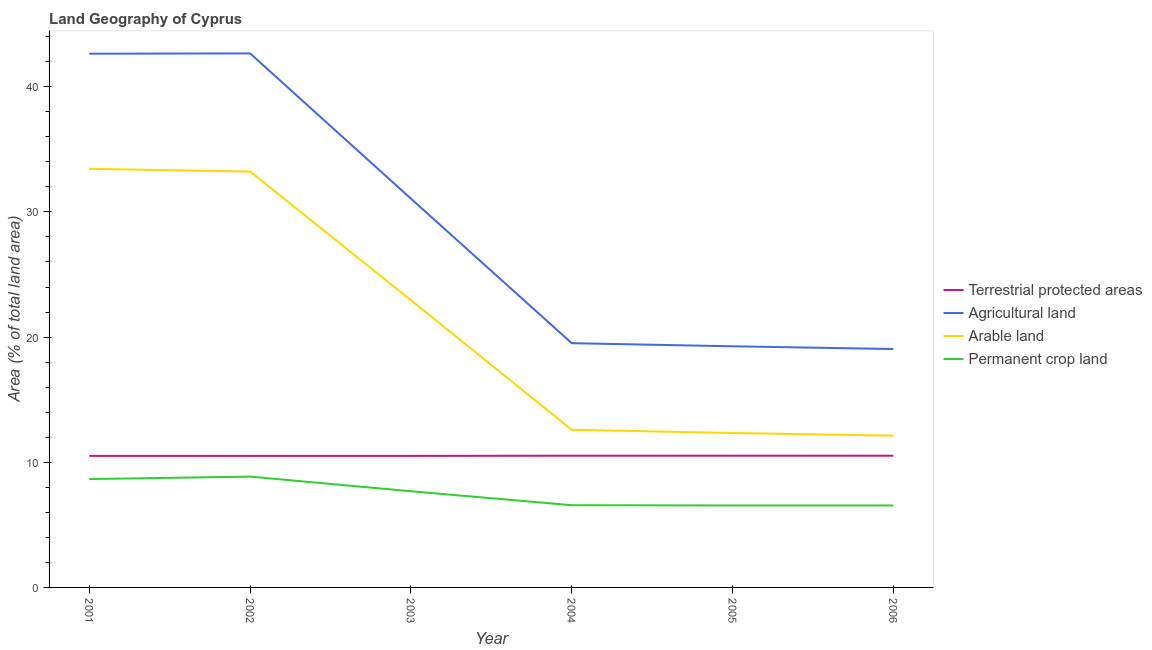How many different coloured lines are there?
Your answer should be compact. 4. What is the percentage of land under terrestrial protection in 2006?
Give a very brief answer. 10.52. Across all years, what is the maximum percentage of area under permanent crop land?
Your answer should be very brief. 8.85. Across all years, what is the minimum percentage of area under agricultural land?
Keep it short and to the point. 19.05. In which year was the percentage of land under terrestrial protection minimum?
Offer a terse response. 2001. What is the total percentage of area under agricultural land in the graph?
Your response must be concise. 174.19. What is the difference between the percentage of land under terrestrial protection in 2001 and that in 2005?
Provide a succinct answer. -0.02. What is the difference between the percentage of area under arable land in 2004 and the percentage of area under permanent crop land in 2006?
Make the answer very short. 6.05. What is the average percentage of area under agricultural land per year?
Offer a very short reply. 29.03. In the year 2001, what is the difference between the percentage of area under agricultural land and percentage of area under arable land?
Ensure brevity in your answer.  9.2. What is the ratio of the percentage of area under permanent crop land in 2003 to that in 2005?
Offer a terse response. 1.17. Is the percentage of land under terrestrial protection in 2002 less than that in 2004?
Make the answer very short. Yes. What is the difference between the highest and the second highest percentage of area under permanent crop land?
Provide a succinct answer. 0.19. What is the difference between the highest and the lowest percentage of area under agricultural land?
Your answer should be compact. 23.61. Is it the case that in every year, the sum of the percentage of area under agricultural land and percentage of area under arable land is greater than the sum of percentage of land under terrestrial protection and percentage of area under permanent crop land?
Make the answer very short. Yes. Is it the case that in every year, the sum of the percentage of land under terrestrial protection and percentage of area under agricultural land is greater than the percentage of area under arable land?
Give a very brief answer. Yes. Is the percentage of area under permanent crop land strictly less than the percentage of area under arable land over the years?
Give a very brief answer. Yes. How many years are there in the graph?
Keep it short and to the point. 6. Are the values on the major ticks of Y-axis written in scientific E-notation?
Offer a very short reply. No. Does the graph contain any zero values?
Keep it short and to the point. No. Does the graph contain grids?
Provide a succinct answer. No. How many legend labels are there?
Keep it short and to the point. 4. How are the legend labels stacked?
Keep it short and to the point. Vertical. What is the title of the graph?
Your response must be concise. Land Geography of Cyprus. Does "Public sector management" appear as one of the legend labels in the graph?
Provide a succinct answer. No. What is the label or title of the Y-axis?
Keep it short and to the point. Area (% of total land area). What is the Area (% of total land area) in Terrestrial protected areas in 2001?
Offer a very short reply. 10.51. What is the Area (% of total land area) in Agricultural land in 2001?
Offer a terse response. 42.64. What is the Area (% of total land area) of Arable land in 2001?
Provide a short and direct response. 33.44. What is the Area (% of total land area) of Permanent crop land in 2001?
Provide a short and direct response. 8.66. What is the Area (% of total land area) of Terrestrial protected areas in 2002?
Offer a very short reply. 10.51. What is the Area (% of total land area) of Agricultural land in 2002?
Ensure brevity in your answer.  42.66. What is the Area (% of total land area) in Arable land in 2002?
Offer a very short reply. 33.23. What is the Area (% of total land area) in Permanent crop land in 2002?
Give a very brief answer. 8.85. What is the Area (% of total land area) in Terrestrial protected areas in 2003?
Your response must be concise. 10.51. What is the Area (% of total land area) of Agricultural land in 2003?
Provide a short and direct response. 31.06. What is the Area (% of total land area) of Arable land in 2003?
Your response must be concise. 22.94. What is the Area (% of total land area) in Permanent crop land in 2003?
Keep it short and to the point. 7.68. What is the Area (% of total land area) of Terrestrial protected areas in 2004?
Your answer should be compact. 10.52. What is the Area (% of total land area) of Agricultural land in 2004?
Ensure brevity in your answer.  19.51. What is the Area (% of total land area) in Arable land in 2004?
Your answer should be very brief. 12.6. What is the Area (% of total land area) in Permanent crop land in 2004?
Ensure brevity in your answer.  6.57. What is the Area (% of total land area) of Terrestrial protected areas in 2005?
Provide a short and direct response. 10.52. What is the Area (% of total land area) in Agricultural land in 2005?
Offer a very short reply. 19.26. What is the Area (% of total land area) of Arable land in 2005?
Provide a succinct answer. 12.34. What is the Area (% of total land area) in Permanent crop land in 2005?
Your response must be concise. 6.55. What is the Area (% of total land area) in Terrestrial protected areas in 2006?
Keep it short and to the point. 10.52. What is the Area (% of total land area) in Agricultural land in 2006?
Ensure brevity in your answer.  19.05. What is the Area (% of total land area) of Arable land in 2006?
Make the answer very short. 12.12. What is the Area (% of total land area) of Permanent crop land in 2006?
Give a very brief answer. 6.55. Across all years, what is the maximum Area (% of total land area) of Terrestrial protected areas?
Your response must be concise. 10.52. Across all years, what is the maximum Area (% of total land area) in Agricultural land?
Give a very brief answer. 42.66. Across all years, what is the maximum Area (% of total land area) of Arable land?
Ensure brevity in your answer.  33.44. Across all years, what is the maximum Area (% of total land area) of Permanent crop land?
Your answer should be very brief. 8.85. Across all years, what is the minimum Area (% of total land area) in Terrestrial protected areas?
Offer a very short reply. 10.51. Across all years, what is the minimum Area (% of total land area) in Agricultural land?
Offer a very short reply. 19.05. Across all years, what is the minimum Area (% of total land area) in Arable land?
Make the answer very short. 12.12. Across all years, what is the minimum Area (% of total land area) of Permanent crop land?
Ensure brevity in your answer.  6.55. What is the total Area (% of total land area) in Terrestrial protected areas in the graph?
Your response must be concise. 63.1. What is the total Area (% of total land area) in Agricultural land in the graph?
Make the answer very short. 174.19. What is the total Area (% of total land area) of Arable land in the graph?
Keep it short and to the point. 126.67. What is the total Area (% of total land area) in Permanent crop land in the graph?
Your response must be concise. 44.86. What is the difference between the Area (% of total land area) in Terrestrial protected areas in 2001 and that in 2002?
Your answer should be very brief. 0. What is the difference between the Area (% of total land area) of Agricultural land in 2001 and that in 2002?
Offer a terse response. -0.02. What is the difference between the Area (% of total land area) of Arable land in 2001 and that in 2002?
Provide a short and direct response. 0.22. What is the difference between the Area (% of total land area) in Permanent crop land in 2001 and that in 2002?
Offer a terse response. -0.19. What is the difference between the Area (% of total land area) of Agricultural land in 2001 and that in 2003?
Your answer should be compact. 11.58. What is the difference between the Area (% of total land area) in Arable land in 2001 and that in 2003?
Your answer should be very brief. 10.5. What is the difference between the Area (% of total land area) in Terrestrial protected areas in 2001 and that in 2004?
Ensure brevity in your answer.  -0.02. What is the difference between the Area (% of total land area) in Agricultural land in 2001 and that in 2004?
Offer a terse response. 23.13. What is the difference between the Area (% of total land area) in Arable land in 2001 and that in 2004?
Keep it short and to the point. 20.84. What is the difference between the Area (% of total land area) in Permanent crop land in 2001 and that in 2004?
Make the answer very short. 2.09. What is the difference between the Area (% of total land area) of Terrestrial protected areas in 2001 and that in 2005?
Keep it short and to the point. -0.02. What is the difference between the Area (% of total land area) of Agricultural land in 2001 and that in 2005?
Your response must be concise. 23.38. What is the difference between the Area (% of total land area) of Arable land in 2001 and that in 2005?
Keep it short and to the point. 21.1. What is the difference between the Area (% of total land area) in Permanent crop land in 2001 and that in 2005?
Make the answer very short. 2.11. What is the difference between the Area (% of total land area) in Terrestrial protected areas in 2001 and that in 2006?
Ensure brevity in your answer.  -0.02. What is the difference between the Area (% of total land area) in Agricultural land in 2001 and that in 2006?
Give a very brief answer. 23.59. What is the difference between the Area (% of total land area) in Arable land in 2001 and that in 2006?
Ensure brevity in your answer.  21.32. What is the difference between the Area (% of total land area) of Permanent crop land in 2001 and that in 2006?
Provide a succinct answer. 2.11. What is the difference between the Area (% of total land area) of Terrestrial protected areas in 2002 and that in 2003?
Your answer should be very brief. 0. What is the difference between the Area (% of total land area) in Agricultural land in 2002 and that in 2003?
Keep it short and to the point. 11.6. What is the difference between the Area (% of total land area) of Arable land in 2002 and that in 2003?
Keep it short and to the point. 10.28. What is the difference between the Area (% of total land area) in Permanent crop land in 2002 and that in 2003?
Provide a succinct answer. 1.17. What is the difference between the Area (% of total land area) in Terrestrial protected areas in 2002 and that in 2004?
Provide a short and direct response. -0.02. What is the difference between the Area (% of total land area) in Agricultural land in 2002 and that in 2004?
Make the answer very short. 23.15. What is the difference between the Area (% of total land area) of Arable land in 2002 and that in 2004?
Offer a very short reply. 20.63. What is the difference between the Area (% of total land area) of Permanent crop land in 2002 and that in 2004?
Offer a terse response. 2.28. What is the difference between the Area (% of total land area) of Terrestrial protected areas in 2002 and that in 2005?
Ensure brevity in your answer.  -0.02. What is the difference between the Area (% of total land area) in Agricultural land in 2002 and that in 2005?
Offer a very short reply. 23.4. What is the difference between the Area (% of total land area) in Arable land in 2002 and that in 2005?
Provide a short and direct response. 20.89. What is the difference between the Area (% of total land area) in Permanent crop land in 2002 and that in 2005?
Keep it short and to the point. 2.31. What is the difference between the Area (% of total land area) of Terrestrial protected areas in 2002 and that in 2006?
Offer a very short reply. -0.02. What is the difference between the Area (% of total land area) in Agricultural land in 2002 and that in 2006?
Offer a very short reply. 23.61. What is the difference between the Area (% of total land area) in Arable land in 2002 and that in 2006?
Keep it short and to the point. 21.1. What is the difference between the Area (% of total land area) in Permanent crop land in 2002 and that in 2006?
Offer a terse response. 2.31. What is the difference between the Area (% of total land area) in Terrestrial protected areas in 2003 and that in 2004?
Give a very brief answer. -0.02. What is the difference between the Area (% of total land area) of Agricultural land in 2003 and that in 2004?
Ensure brevity in your answer.  11.55. What is the difference between the Area (% of total land area) of Arable land in 2003 and that in 2004?
Your answer should be very brief. 10.35. What is the difference between the Area (% of total land area) in Permanent crop land in 2003 and that in 2004?
Keep it short and to the point. 1.11. What is the difference between the Area (% of total land area) in Terrestrial protected areas in 2003 and that in 2005?
Provide a succinct answer. -0.02. What is the difference between the Area (% of total land area) in Agricultural land in 2003 and that in 2005?
Your response must be concise. 11.8. What is the difference between the Area (% of total land area) of Arable land in 2003 and that in 2005?
Make the answer very short. 10.61. What is the difference between the Area (% of total land area) in Permanent crop land in 2003 and that in 2005?
Make the answer very short. 1.14. What is the difference between the Area (% of total land area) in Terrestrial protected areas in 2003 and that in 2006?
Make the answer very short. -0.02. What is the difference between the Area (% of total land area) in Agricultural land in 2003 and that in 2006?
Your answer should be very brief. 12.01. What is the difference between the Area (% of total land area) of Arable land in 2003 and that in 2006?
Provide a short and direct response. 10.82. What is the difference between the Area (% of total land area) in Permanent crop land in 2003 and that in 2006?
Offer a very short reply. 1.14. What is the difference between the Area (% of total land area) in Terrestrial protected areas in 2004 and that in 2005?
Your answer should be compact. 0. What is the difference between the Area (% of total land area) in Agricultural land in 2004 and that in 2005?
Ensure brevity in your answer.  0.25. What is the difference between the Area (% of total land area) in Arable land in 2004 and that in 2005?
Make the answer very short. 0.26. What is the difference between the Area (% of total land area) in Permanent crop land in 2004 and that in 2005?
Your answer should be very brief. 0.02. What is the difference between the Area (% of total land area) in Terrestrial protected areas in 2004 and that in 2006?
Provide a short and direct response. 0. What is the difference between the Area (% of total land area) in Agricultural land in 2004 and that in 2006?
Provide a short and direct response. 0.47. What is the difference between the Area (% of total land area) in Arable land in 2004 and that in 2006?
Ensure brevity in your answer.  0.48. What is the difference between the Area (% of total land area) of Permanent crop land in 2004 and that in 2006?
Offer a very short reply. 0.02. What is the difference between the Area (% of total land area) of Agricultural land in 2005 and that in 2006?
Offer a very short reply. 0.22. What is the difference between the Area (% of total land area) of Arable land in 2005 and that in 2006?
Give a very brief answer. 0.22. What is the difference between the Area (% of total land area) in Terrestrial protected areas in 2001 and the Area (% of total land area) in Agricultural land in 2002?
Your response must be concise. -32.15. What is the difference between the Area (% of total land area) of Terrestrial protected areas in 2001 and the Area (% of total land area) of Arable land in 2002?
Your answer should be compact. -22.72. What is the difference between the Area (% of total land area) in Terrestrial protected areas in 2001 and the Area (% of total land area) in Permanent crop land in 2002?
Offer a very short reply. 1.66. What is the difference between the Area (% of total land area) of Agricultural land in 2001 and the Area (% of total land area) of Arable land in 2002?
Give a very brief answer. 9.42. What is the difference between the Area (% of total land area) in Agricultural land in 2001 and the Area (% of total land area) in Permanent crop land in 2002?
Your answer should be very brief. 33.79. What is the difference between the Area (% of total land area) of Arable land in 2001 and the Area (% of total land area) of Permanent crop land in 2002?
Offer a very short reply. 24.59. What is the difference between the Area (% of total land area) in Terrestrial protected areas in 2001 and the Area (% of total land area) in Agricultural land in 2003?
Provide a short and direct response. -20.55. What is the difference between the Area (% of total land area) in Terrestrial protected areas in 2001 and the Area (% of total land area) in Arable land in 2003?
Provide a short and direct response. -12.44. What is the difference between the Area (% of total land area) of Terrestrial protected areas in 2001 and the Area (% of total land area) of Permanent crop land in 2003?
Ensure brevity in your answer.  2.82. What is the difference between the Area (% of total land area) of Agricultural land in 2001 and the Area (% of total land area) of Arable land in 2003?
Ensure brevity in your answer.  19.7. What is the difference between the Area (% of total land area) in Agricultural land in 2001 and the Area (% of total land area) in Permanent crop land in 2003?
Your response must be concise. 34.96. What is the difference between the Area (% of total land area) of Arable land in 2001 and the Area (% of total land area) of Permanent crop land in 2003?
Your answer should be compact. 25.76. What is the difference between the Area (% of total land area) of Terrestrial protected areas in 2001 and the Area (% of total land area) of Agricultural land in 2004?
Your answer should be very brief. -9. What is the difference between the Area (% of total land area) in Terrestrial protected areas in 2001 and the Area (% of total land area) in Arable land in 2004?
Give a very brief answer. -2.09. What is the difference between the Area (% of total land area) of Terrestrial protected areas in 2001 and the Area (% of total land area) of Permanent crop land in 2004?
Ensure brevity in your answer.  3.94. What is the difference between the Area (% of total land area) in Agricultural land in 2001 and the Area (% of total land area) in Arable land in 2004?
Offer a very short reply. 30.04. What is the difference between the Area (% of total land area) of Agricultural land in 2001 and the Area (% of total land area) of Permanent crop land in 2004?
Your answer should be compact. 36.07. What is the difference between the Area (% of total land area) of Arable land in 2001 and the Area (% of total land area) of Permanent crop land in 2004?
Your answer should be compact. 26.87. What is the difference between the Area (% of total land area) of Terrestrial protected areas in 2001 and the Area (% of total land area) of Agricultural land in 2005?
Offer a terse response. -8.76. What is the difference between the Area (% of total land area) of Terrestrial protected areas in 2001 and the Area (% of total land area) of Arable land in 2005?
Ensure brevity in your answer.  -1.83. What is the difference between the Area (% of total land area) in Terrestrial protected areas in 2001 and the Area (% of total land area) in Permanent crop land in 2005?
Provide a short and direct response. 3.96. What is the difference between the Area (% of total land area) in Agricultural land in 2001 and the Area (% of total land area) in Arable land in 2005?
Make the answer very short. 30.3. What is the difference between the Area (% of total land area) of Agricultural land in 2001 and the Area (% of total land area) of Permanent crop land in 2005?
Give a very brief answer. 36.09. What is the difference between the Area (% of total land area) of Arable land in 2001 and the Area (% of total land area) of Permanent crop land in 2005?
Provide a succinct answer. 26.89. What is the difference between the Area (% of total land area) in Terrestrial protected areas in 2001 and the Area (% of total land area) in Agricultural land in 2006?
Provide a short and direct response. -8.54. What is the difference between the Area (% of total land area) of Terrestrial protected areas in 2001 and the Area (% of total land area) of Arable land in 2006?
Keep it short and to the point. -1.61. What is the difference between the Area (% of total land area) of Terrestrial protected areas in 2001 and the Area (% of total land area) of Permanent crop land in 2006?
Provide a succinct answer. 3.96. What is the difference between the Area (% of total land area) of Agricultural land in 2001 and the Area (% of total land area) of Arable land in 2006?
Ensure brevity in your answer.  30.52. What is the difference between the Area (% of total land area) of Agricultural land in 2001 and the Area (% of total land area) of Permanent crop land in 2006?
Ensure brevity in your answer.  36.09. What is the difference between the Area (% of total land area) of Arable land in 2001 and the Area (% of total land area) of Permanent crop land in 2006?
Keep it short and to the point. 26.89. What is the difference between the Area (% of total land area) in Terrestrial protected areas in 2002 and the Area (% of total land area) in Agricultural land in 2003?
Give a very brief answer. -20.55. What is the difference between the Area (% of total land area) of Terrestrial protected areas in 2002 and the Area (% of total land area) of Arable land in 2003?
Ensure brevity in your answer.  -12.44. What is the difference between the Area (% of total land area) of Terrestrial protected areas in 2002 and the Area (% of total land area) of Permanent crop land in 2003?
Provide a short and direct response. 2.82. What is the difference between the Area (% of total land area) of Agricultural land in 2002 and the Area (% of total land area) of Arable land in 2003?
Your response must be concise. 19.72. What is the difference between the Area (% of total land area) of Agricultural land in 2002 and the Area (% of total land area) of Permanent crop land in 2003?
Provide a succinct answer. 34.98. What is the difference between the Area (% of total land area) in Arable land in 2002 and the Area (% of total land area) in Permanent crop land in 2003?
Keep it short and to the point. 25.54. What is the difference between the Area (% of total land area) of Terrestrial protected areas in 2002 and the Area (% of total land area) of Agricultural land in 2004?
Your answer should be compact. -9. What is the difference between the Area (% of total land area) of Terrestrial protected areas in 2002 and the Area (% of total land area) of Arable land in 2004?
Provide a succinct answer. -2.09. What is the difference between the Area (% of total land area) in Terrestrial protected areas in 2002 and the Area (% of total land area) in Permanent crop land in 2004?
Provide a succinct answer. 3.94. What is the difference between the Area (% of total land area) of Agricultural land in 2002 and the Area (% of total land area) of Arable land in 2004?
Give a very brief answer. 30.06. What is the difference between the Area (% of total land area) of Agricultural land in 2002 and the Area (% of total land area) of Permanent crop land in 2004?
Provide a short and direct response. 36.09. What is the difference between the Area (% of total land area) of Arable land in 2002 and the Area (% of total land area) of Permanent crop land in 2004?
Give a very brief answer. 26.66. What is the difference between the Area (% of total land area) in Terrestrial protected areas in 2002 and the Area (% of total land area) in Agricultural land in 2005?
Your answer should be very brief. -8.76. What is the difference between the Area (% of total land area) in Terrestrial protected areas in 2002 and the Area (% of total land area) in Arable land in 2005?
Offer a very short reply. -1.83. What is the difference between the Area (% of total land area) in Terrestrial protected areas in 2002 and the Area (% of total land area) in Permanent crop land in 2005?
Your answer should be compact. 3.96. What is the difference between the Area (% of total land area) in Agricultural land in 2002 and the Area (% of total land area) in Arable land in 2005?
Give a very brief answer. 30.32. What is the difference between the Area (% of total land area) of Agricultural land in 2002 and the Area (% of total land area) of Permanent crop land in 2005?
Offer a terse response. 36.11. What is the difference between the Area (% of total land area) in Arable land in 2002 and the Area (% of total land area) in Permanent crop land in 2005?
Give a very brief answer. 26.68. What is the difference between the Area (% of total land area) of Terrestrial protected areas in 2002 and the Area (% of total land area) of Agricultural land in 2006?
Your response must be concise. -8.54. What is the difference between the Area (% of total land area) of Terrestrial protected areas in 2002 and the Area (% of total land area) of Arable land in 2006?
Your answer should be very brief. -1.61. What is the difference between the Area (% of total land area) of Terrestrial protected areas in 2002 and the Area (% of total land area) of Permanent crop land in 2006?
Keep it short and to the point. 3.96. What is the difference between the Area (% of total land area) of Agricultural land in 2002 and the Area (% of total land area) of Arable land in 2006?
Your response must be concise. 30.54. What is the difference between the Area (% of total land area) in Agricultural land in 2002 and the Area (% of total land area) in Permanent crop land in 2006?
Ensure brevity in your answer.  36.11. What is the difference between the Area (% of total land area) of Arable land in 2002 and the Area (% of total land area) of Permanent crop land in 2006?
Keep it short and to the point. 26.68. What is the difference between the Area (% of total land area) of Terrestrial protected areas in 2003 and the Area (% of total land area) of Agricultural land in 2004?
Give a very brief answer. -9. What is the difference between the Area (% of total land area) in Terrestrial protected areas in 2003 and the Area (% of total land area) in Arable land in 2004?
Offer a very short reply. -2.09. What is the difference between the Area (% of total land area) of Terrestrial protected areas in 2003 and the Area (% of total land area) of Permanent crop land in 2004?
Offer a terse response. 3.94. What is the difference between the Area (% of total land area) of Agricultural land in 2003 and the Area (% of total land area) of Arable land in 2004?
Provide a short and direct response. 18.46. What is the difference between the Area (% of total land area) in Agricultural land in 2003 and the Area (% of total land area) in Permanent crop land in 2004?
Provide a succinct answer. 24.49. What is the difference between the Area (% of total land area) of Arable land in 2003 and the Area (% of total land area) of Permanent crop land in 2004?
Your answer should be compact. 16.37. What is the difference between the Area (% of total land area) in Terrestrial protected areas in 2003 and the Area (% of total land area) in Agricultural land in 2005?
Your answer should be compact. -8.76. What is the difference between the Area (% of total land area) of Terrestrial protected areas in 2003 and the Area (% of total land area) of Arable land in 2005?
Offer a terse response. -1.83. What is the difference between the Area (% of total land area) in Terrestrial protected areas in 2003 and the Area (% of total land area) in Permanent crop land in 2005?
Ensure brevity in your answer.  3.96. What is the difference between the Area (% of total land area) in Agricultural land in 2003 and the Area (% of total land area) in Arable land in 2005?
Your answer should be compact. 18.72. What is the difference between the Area (% of total land area) of Agricultural land in 2003 and the Area (% of total land area) of Permanent crop land in 2005?
Provide a short and direct response. 24.51. What is the difference between the Area (% of total land area) in Arable land in 2003 and the Area (% of total land area) in Permanent crop land in 2005?
Ensure brevity in your answer.  16.4. What is the difference between the Area (% of total land area) in Terrestrial protected areas in 2003 and the Area (% of total land area) in Agricultural land in 2006?
Offer a terse response. -8.54. What is the difference between the Area (% of total land area) of Terrestrial protected areas in 2003 and the Area (% of total land area) of Arable land in 2006?
Ensure brevity in your answer.  -1.61. What is the difference between the Area (% of total land area) of Terrestrial protected areas in 2003 and the Area (% of total land area) of Permanent crop land in 2006?
Ensure brevity in your answer.  3.96. What is the difference between the Area (% of total land area) of Agricultural land in 2003 and the Area (% of total land area) of Arable land in 2006?
Make the answer very short. 18.94. What is the difference between the Area (% of total land area) in Agricultural land in 2003 and the Area (% of total land area) in Permanent crop land in 2006?
Give a very brief answer. 24.51. What is the difference between the Area (% of total land area) in Arable land in 2003 and the Area (% of total land area) in Permanent crop land in 2006?
Your answer should be very brief. 16.4. What is the difference between the Area (% of total land area) in Terrestrial protected areas in 2004 and the Area (% of total land area) in Agricultural land in 2005?
Keep it short and to the point. -8.74. What is the difference between the Area (% of total land area) in Terrestrial protected areas in 2004 and the Area (% of total land area) in Arable land in 2005?
Ensure brevity in your answer.  -1.81. What is the difference between the Area (% of total land area) of Terrestrial protected areas in 2004 and the Area (% of total land area) of Permanent crop land in 2005?
Ensure brevity in your answer.  3.98. What is the difference between the Area (% of total land area) in Agricultural land in 2004 and the Area (% of total land area) in Arable land in 2005?
Give a very brief answer. 7.18. What is the difference between the Area (% of total land area) in Agricultural land in 2004 and the Area (% of total land area) in Permanent crop land in 2005?
Give a very brief answer. 12.97. What is the difference between the Area (% of total land area) in Arable land in 2004 and the Area (% of total land area) in Permanent crop land in 2005?
Offer a very short reply. 6.05. What is the difference between the Area (% of total land area) of Terrestrial protected areas in 2004 and the Area (% of total land area) of Agricultural land in 2006?
Provide a short and direct response. -8.52. What is the difference between the Area (% of total land area) in Terrestrial protected areas in 2004 and the Area (% of total land area) in Arable land in 2006?
Provide a succinct answer. -1.6. What is the difference between the Area (% of total land area) in Terrestrial protected areas in 2004 and the Area (% of total land area) in Permanent crop land in 2006?
Offer a very short reply. 3.98. What is the difference between the Area (% of total land area) in Agricultural land in 2004 and the Area (% of total land area) in Arable land in 2006?
Your answer should be very brief. 7.39. What is the difference between the Area (% of total land area) in Agricultural land in 2004 and the Area (% of total land area) in Permanent crop land in 2006?
Make the answer very short. 12.97. What is the difference between the Area (% of total land area) in Arable land in 2004 and the Area (% of total land area) in Permanent crop land in 2006?
Provide a short and direct response. 6.05. What is the difference between the Area (% of total land area) in Terrestrial protected areas in 2005 and the Area (% of total land area) in Agricultural land in 2006?
Make the answer very short. -8.52. What is the difference between the Area (% of total land area) of Terrestrial protected areas in 2005 and the Area (% of total land area) of Arable land in 2006?
Provide a short and direct response. -1.6. What is the difference between the Area (% of total land area) of Terrestrial protected areas in 2005 and the Area (% of total land area) of Permanent crop land in 2006?
Ensure brevity in your answer.  3.98. What is the difference between the Area (% of total land area) in Agricultural land in 2005 and the Area (% of total land area) in Arable land in 2006?
Your response must be concise. 7.14. What is the difference between the Area (% of total land area) of Agricultural land in 2005 and the Area (% of total land area) of Permanent crop land in 2006?
Your answer should be very brief. 12.72. What is the difference between the Area (% of total land area) of Arable land in 2005 and the Area (% of total land area) of Permanent crop land in 2006?
Offer a very short reply. 5.79. What is the average Area (% of total land area) in Terrestrial protected areas per year?
Offer a very short reply. 10.52. What is the average Area (% of total land area) in Agricultural land per year?
Your answer should be very brief. 29.03. What is the average Area (% of total land area) of Arable land per year?
Provide a succinct answer. 21.11. What is the average Area (% of total land area) of Permanent crop land per year?
Provide a succinct answer. 7.48. In the year 2001, what is the difference between the Area (% of total land area) of Terrestrial protected areas and Area (% of total land area) of Agricultural land?
Your answer should be very brief. -32.13. In the year 2001, what is the difference between the Area (% of total land area) in Terrestrial protected areas and Area (% of total land area) in Arable land?
Your answer should be very brief. -22.93. In the year 2001, what is the difference between the Area (% of total land area) in Terrestrial protected areas and Area (% of total land area) in Permanent crop land?
Ensure brevity in your answer.  1.85. In the year 2001, what is the difference between the Area (% of total land area) in Agricultural land and Area (% of total land area) in Arable land?
Your answer should be very brief. 9.2. In the year 2001, what is the difference between the Area (% of total land area) of Agricultural land and Area (% of total land area) of Permanent crop land?
Keep it short and to the point. 33.98. In the year 2001, what is the difference between the Area (% of total land area) of Arable land and Area (% of total land area) of Permanent crop land?
Ensure brevity in your answer.  24.78. In the year 2002, what is the difference between the Area (% of total land area) of Terrestrial protected areas and Area (% of total land area) of Agricultural land?
Keep it short and to the point. -32.15. In the year 2002, what is the difference between the Area (% of total land area) in Terrestrial protected areas and Area (% of total land area) in Arable land?
Provide a succinct answer. -22.72. In the year 2002, what is the difference between the Area (% of total land area) in Terrestrial protected areas and Area (% of total land area) in Permanent crop land?
Offer a terse response. 1.66. In the year 2002, what is the difference between the Area (% of total land area) of Agricultural land and Area (% of total land area) of Arable land?
Offer a terse response. 9.44. In the year 2002, what is the difference between the Area (% of total land area) of Agricultural land and Area (% of total land area) of Permanent crop land?
Make the answer very short. 33.81. In the year 2002, what is the difference between the Area (% of total land area) in Arable land and Area (% of total land area) in Permanent crop land?
Offer a terse response. 24.37. In the year 2003, what is the difference between the Area (% of total land area) of Terrestrial protected areas and Area (% of total land area) of Agricultural land?
Offer a very short reply. -20.55. In the year 2003, what is the difference between the Area (% of total land area) of Terrestrial protected areas and Area (% of total land area) of Arable land?
Offer a very short reply. -12.44. In the year 2003, what is the difference between the Area (% of total land area) in Terrestrial protected areas and Area (% of total land area) in Permanent crop land?
Make the answer very short. 2.82. In the year 2003, what is the difference between the Area (% of total land area) in Agricultural land and Area (% of total land area) in Arable land?
Provide a short and direct response. 8.12. In the year 2003, what is the difference between the Area (% of total land area) of Agricultural land and Area (% of total land area) of Permanent crop land?
Keep it short and to the point. 23.38. In the year 2003, what is the difference between the Area (% of total land area) of Arable land and Area (% of total land area) of Permanent crop land?
Your answer should be very brief. 15.26. In the year 2004, what is the difference between the Area (% of total land area) in Terrestrial protected areas and Area (% of total land area) in Agricultural land?
Make the answer very short. -8.99. In the year 2004, what is the difference between the Area (% of total land area) of Terrestrial protected areas and Area (% of total land area) of Arable land?
Give a very brief answer. -2.07. In the year 2004, what is the difference between the Area (% of total land area) of Terrestrial protected areas and Area (% of total land area) of Permanent crop land?
Your answer should be compact. 3.95. In the year 2004, what is the difference between the Area (% of total land area) in Agricultural land and Area (% of total land area) in Arable land?
Make the answer very short. 6.92. In the year 2004, what is the difference between the Area (% of total land area) in Agricultural land and Area (% of total land area) in Permanent crop land?
Your answer should be very brief. 12.94. In the year 2004, what is the difference between the Area (% of total land area) in Arable land and Area (% of total land area) in Permanent crop land?
Keep it short and to the point. 6.03. In the year 2005, what is the difference between the Area (% of total land area) of Terrestrial protected areas and Area (% of total land area) of Agricultural land?
Make the answer very short. -8.74. In the year 2005, what is the difference between the Area (% of total land area) of Terrestrial protected areas and Area (% of total land area) of Arable land?
Ensure brevity in your answer.  -1.81. In the year 2005, what is the difference between the Area (% of total land area) of Terrestrial protected areas and Area (% of total land area) of Permanent crop land?
Your answer should be very brief. 3.98. In the year 2005, what is the difference between the Area (% of total land area) of Agricultural land and Area (% of total land area) of Arable land?
Offer a very short reply. 6.93. In the year 2005, what is the difference between the Area (% of total land area) in Agricultural land and Area (% of total land area) in Permanent crop land?
Give a very brief answer. 12.72. In the year 2005, what is the difference between the Area (% of total land area) in Arable land and Area (% of total land area) in Permanent crop land?
Provide a short and direct response. 5.79. In the year 2006, what is the difference between the Area (% of total land area) of Terrestrial protected areas and Area (% of total land area) of Agricultural land?
Offer a terse response. -8.52. In the year 2006, what is the difference between the Area (% of total land area) of Terrestrial protected areas and Area (% of total land area) of Arable land?
Offer a very short reply. -1.6. In the year 2006, what is the difference between the Area (% of total land area) in Terrestrial protected areas and Area (% of total land area) in Permanent crop land?
Provide a succinct answer. 3.98. In the year 2006, what is the difference between the Area (% of total land area) in Agricultural land and Area (% of total land area) in Arable land?
Your answer should be compact. 6.93. In the year 2006, what is the difference between the Area (% of total land area) of Arable land and Area (% of total land area) of Permanent crop land?
Ensure brevity in your answer.  5.57. What is the ratio of the Area (% of total land area) of Arable land in 2001 to that in 2002?
Your answer should be compact. 1.01. What is the ratio of the Area (% of total land area) in Agricultural land in 2001 to that in 2003?
Ensure brevity in your answer.  1.37. What is the ratio of the Area (% of total land area) of Arable land in 2001 to that in 2003?
Ensure brevity in your answer.  1.46. What is the ratio of the Area (% of total land area) of Permanent crop land in 2001 to that in 2003?
Provide a short and direct response. 1.13. What is the ratio of the Area (% of total land area) in Agricultural land in 2001 to that in 2004?
Give a very brief answer. 2.19. What is the ratio of the Area (% of total land area) in Arable land in 2001 to that in 2004?
Your answer should be very brief. 2.65. What is the ratio of the Area (% of total land area) of Permanent crop land in 2001 to that in 2004?
Your answer should be compact. 1.32. What is the ratio of the Area (% of total land area) of Terrestrial protected areas in 2001 to that in 2005?
Provide a succinct answer. 1. What is the ratio of the Area (% of total land area) in Agricultural land in 2001 to that in 2005?
Provide a short and direct response. 2.21. What is the ratio of the Area (% of total land area) of Arable land in 2001 to that in 2005?
Provide a succinct answer. 2.71. What is the ratio of the Area (% of total land area) in Permanent crop land in 2001 to that in 2005?
Your answer should be compact. 1.32. What is the ratio of the Area (% of total land area) in Agricultural land in 2001 to that in 2006?
Make the answer very short. 2.24. What is the ratio of the Area (% of total land area) of Arable land in 2001 to that in 2006?
Make the answer very short. 2.76. What is the ratio of the Area (% of total land area) in Permanent crop land in 2001 to that in 2006?
Provide a succinct answer. 1.32. What is the ratio of the Area (% of total land area) in Agricultural land in 2002 to that in 2003?
Your answer should be compact. 1.37. What is the ratio of the Area (% of total land area) in Arable land in 2002 to that in 2003?
Make the answer very short. 1.45. What is the ratio of the Area (% of total land area) of Permanent crop land in 2002 to that in 2003?
Your answer should be very brief. 1.15. What is the ratio of the Area (% of total land area) in Agricultural land in 2002 to that in 2004?
Provide a succinct answer. 2.19. What is the ratio of the Area (% of total land area) in Arable land in 2002 to that in 2004?
Offer a very short reply. 2.64. What is the ratio of the Area (% of total land area) of Permanent crop land in 2002 to that in 2004?
Give a very brief answer. 1.35. What is the ratio of the Area (% of total land area) in Terrestrial protected areas in 2002 to that in 2005?
Give a very brief answer. 1. What is the ratio of the Area (% of total land area) in Agricultural land in 2002 to that in 2005?
Provide a short and direct response. 2.21. What is the ratio of the Area (% of total land area) in Arable land in 2002 to that in 2005?
Give a very brief answer. 2.69. What is the ratio of the Area (% of total land area) in Permanent crop land in 2002 to that in 2005?
Your response must be concise. 1.35. What is the ratio of the Area (% of total land area) of Terrestrial protected areas in 2002 to that in 2006?
Ensure brevity in your answer.  1. What is the ratio of the Area (% of total land area) of Agricultural land in 2002 to that in 2006?
Give a very brief answer. 2.24. What is the ratio of the Area (% of total land area) in Arable land in 2002 to that in 2006?
Your answer should be compact. 2.74. What is the ratio of the Area (% of total land area) of Permanent crop land in 2002 to that in 2006?
Give a very brief answer. 1.35. What is the ratio of the Area (% of total land area) in Terrestrial protected areas in 2003 to that in 2004?
Ensure brevity in your answer.  1. What is the ratio of the Area (% of total land area) in Agricultural land in 2003 to that in 2004?
Offer a terse response. 1.59. What is the ratio of the Area (% of total land area) of Arable land in 2003 to that in 2004?
Offer a terse response. 1.82. What is the ratio of the Area (% of total land area) of Permanent crop land in 2003 to that in 2004?
Make the answer very short. 1.17. What is the ratio of the Area (% of total land area) of Agricultural land in 2003 to that in 2005?
Provide a short and direct response. 1.61. What is the ratio of the Area (% of total land area) of Arable land in 2003 to that in 2005?
Give a very brief answer. 1.86. What is the ratio of the Area (% of total land area) of Permanent crop land in 2003 to that in 2005?
Make the answer very short. 1.17. What is the ratio of the Area (% of total land area) in Agricultural land in 2003 to that in 2006?
Your answer should be very brief. 1.63. What is the ratio of the Area (% of total land area) in Arable land in 2003 to that in 2006?
Provide a short and direct response. 1.89. What is the ratio of the Area (% of total land area) of Permanent crop land in 2003 to that in 2006?
Provide a short and direct response. 1.17. What is the ratio of the Area (% of total land area) in Agricultural land in 2004 to that in 2005?
Keep it short and to the point. 1.01. What is the ratio of the Area (% of total land area) in Arable land in 2004 to that in 2005?
Provide a short and direct response. 1.02. What is the ratio of the Area (% of total land area) in Agricultural land in 2004 to that in 2006?
Offer a terse response. 1.02. What is the ratio of the Area (% of total land area) of Arable land in 2004 to that in 2006?
Provide a succinct answer. 1.04. What is the ratio of the Area (% of total land area) of Permanent crop land in 2004 to that in 2006?
Ensure brevity in your answer.  1. What is the ratio of the Area (% of total land area) of Agricultural land in 2005 to that in 2006?
Make the answer very short. 1.01. What is the ratio of the Area (% of total land area) of Arable land in 2005 to that in 2006?
Make the answer very short. 1.02. What is the difference between the highest and the second highest Area (% of total land area) of Agricultural land?
Your answer should be very brief. 0.02. What is the difference between the highest and the second highest Area (% of total land area) in Arable land?
Offer a terse response. 0.22. What is the difference between the highest and the second highest Area (% of total land area) in Permanent crop land?
Make the answer very short. 0.19. What is the difference between the highest and the lowest Area (% of total land area) in Terrestrial protected areas?
Your answer should be very brief. 0.02. What is the difference between the highest and the lowest Area (% of total land area) of Agricultural land?
Your answer should be very brief. 23.61. What is the difference between the highest and the lowest Area (% of total land area) in Arable land?
Your answer should be compact. 21.32. What is the difference between the highest and the lowest Area (% of total land area) in Permanent crop land?
Your answer should be very brief. 2.31. 